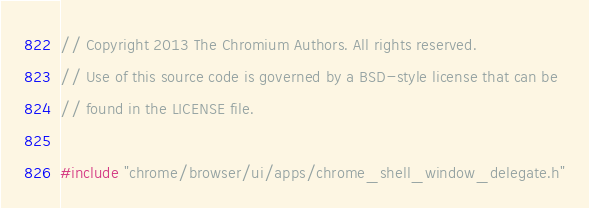<code> <loc_0><loc_0><loc_500><loc_500><_ObjectiveC_>// Copyright 2013 The Chromium Authors. All rights reserved.
// Use of this source code is governed by a BSD-style license that can be
// found in the LICENSE file.

#include "chrome/browser/ui/apps/chrome_shell_window_delegate.h"
</code> 